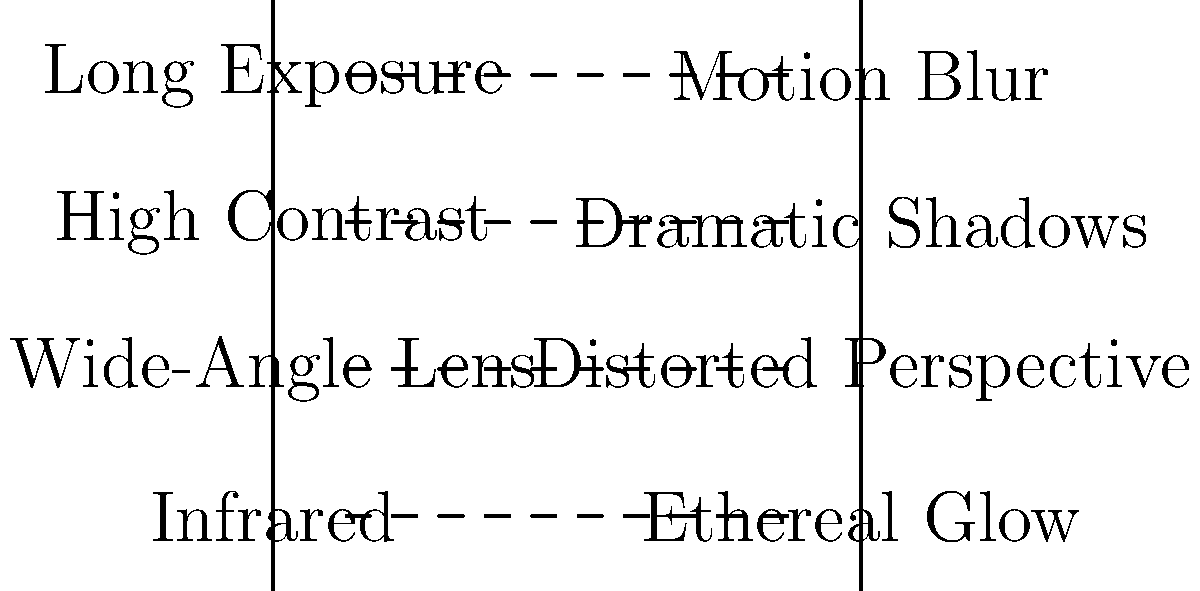Match the photographic techniques on the left with their corresponding visual effects on ruin imagery on the right. Which technique would you recommend to a photographer aiming to capture the passage of time in ancient ruins? To answer this question, let's analyze each technique and its effect:

1. Long Exposure: This technique involves using a slow shutter speed, allowing more light to enter the camera over an extended period. In ruin photography, this creates a Motion Blur effect, which can show the movement of clouds, water, or even stars against the static ruins, symbolizing the passage of time.

2. High Contrast: This technique emphasizes the difference between light and dark areas in an image. It results in Dramatic Shadows, which can accentuate the textures and details of ruins, creating a more intense and moody atmosphere.

3. Wide-Angle Lens: This type of lens captures a broader field of view than the human eye. In ruin photography, it creates a Distorted Perspective, which can make the ruins appear more imposing or vast, emphasizing their scale and architectural features.

4. Infrared: This technique uses special filters or modified cameras to capture light in the infrared spectrum, invisible to the human eye. It produces an Ethereal Glow effect, giving ruins a dreamlike, otherworldly appearance.

To capture the passage of time in ancient ruins, the Long Exposure technique would be most appropriate. It allows the photographer to juxtapose the static, enduring nature of the ruins against the movement of natural elements like clouds or water, visually representing the concept of time passing around these ancient structures.
Answer: Long Exposure 